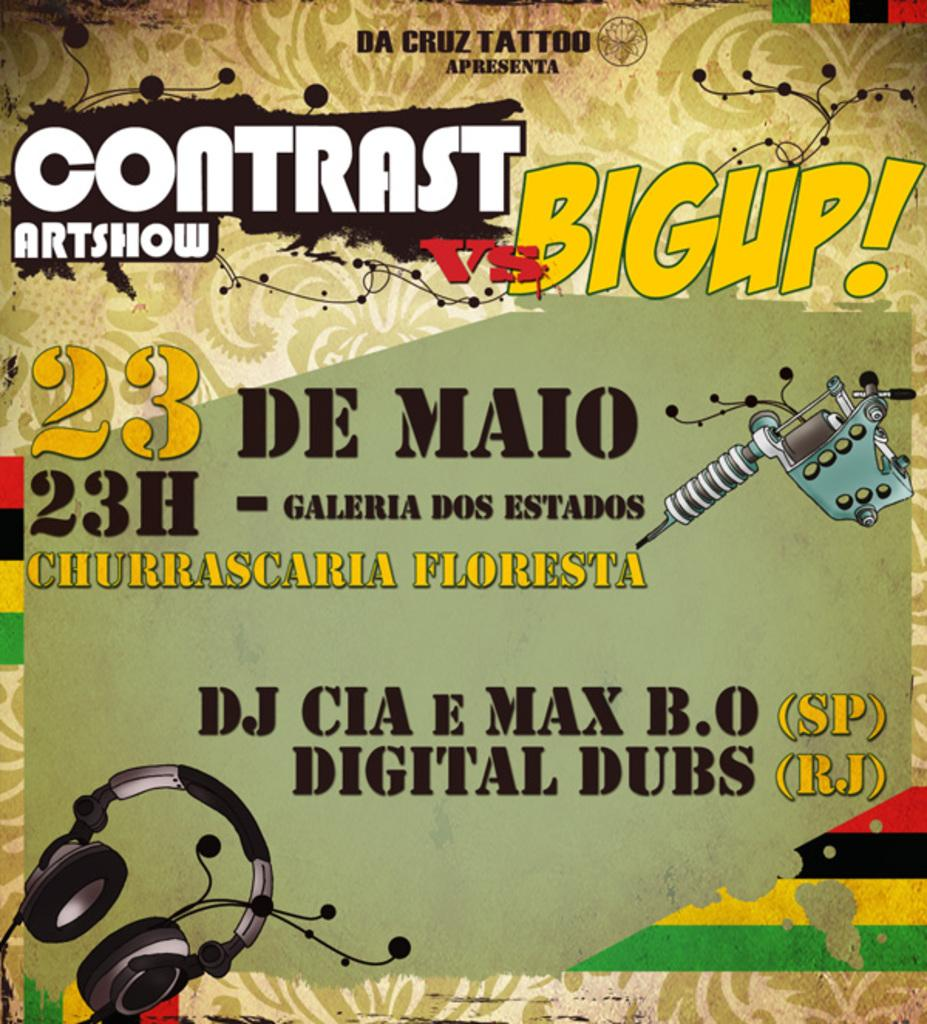<image>
Create a compact narrative representing the image presented. A music concert with DJ CIA and digital Dubs is being advertised on a poster. 